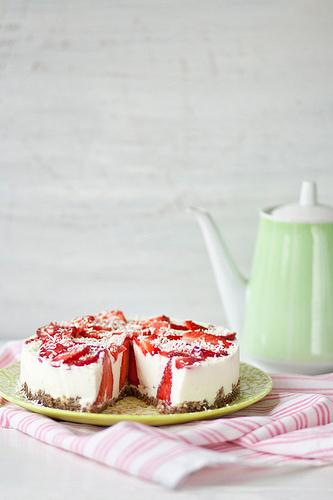How many objects are there on the table in total?  There are 20 objects on the table in total. Determine the complexity of the image based on the given information about objects, locations, and interactions. The image has a moderate level of complexity due to the variety of objects, their positions and sizes, and the interactions between them. What are the colors of the table and tablecloth in the image? The table surface colors are clean blue, shiny white, and the tablecloth has white portions and red stripes. Please provide a description of the cakes shown in the picture. There are two cakes: a white cake topped with a strawberry and white sprinkles and another one with cream surface and graham cracker crust. Assuming the objects are interacting with each other, explain a possible story behind the image. The image depicts a festive gathering, where guests are presented with a beautifully arranged table offering delicious cakes and pies, served on plates, with a jug and teapot for drinks. Please provide a high-level summary of the image contents. The image features a variety of dessert items including cakes, pies, and tableware such as plates, a jug, and a teapot on a table with a striped tablecloth. Estimate the overall quality of the image based on the given information about objects and their sizes. The image quality seems to be sufficient as the objects have clear positions, sizes, and discernible details. Briefly describe the main objects and their interactions in the scene. The main objects are cakes, pies, plates, a jug, teapot, and tablecloth. The pies are on plates, a cake is on a yellow plate, and the jug and teapot sit on the table. What is the sentiment conveyed by the image? The sentiment of the image is positive and inviting, as it showcases a tempting array of desserts and tableware. 